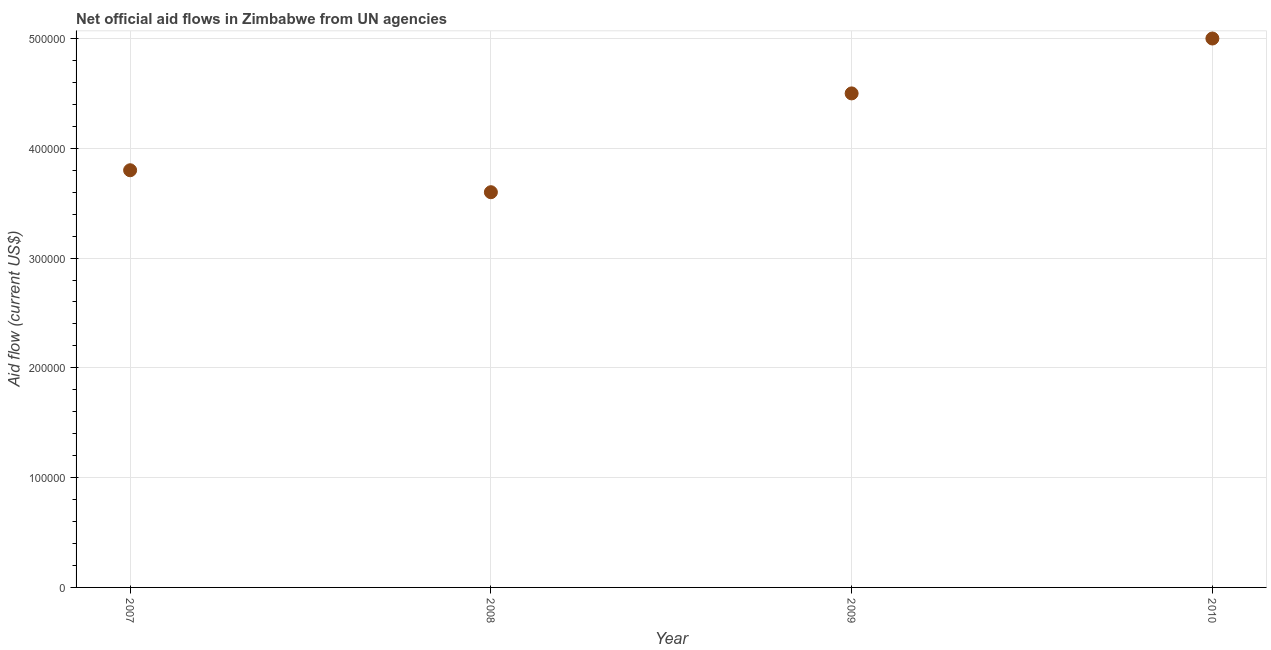What is the net official flows from un agencies in 2010?
Offer a very short reply. 5.00e+05. Across all years, what is the maximum net official flows from un agencies?
Keep it short and to the point. 5.00e+05. Across all years, what is the minimum net official flows from un agencies?
Offer a very short reply. 3.60e+05. In which year was the net official flows from un agencies maximum?
Offer a terse response. 2010. In which year was the net official flows from un agencies minimum?
Your response must be concise. 2008. What is the sum of the net official flows from un agencies?
Offer a terse response. 1.69e+06. What is the difference between the net official flows from un agencies in 2007 and 2008?
Make the answer very short. 2.00e+04. What is the average net official flows from un agencies per year?
Ensure brevity in your answer.  4.22e+05. What is the median net official flows from un agencies?
Your answer should be very brief. 4.15e+05. In how many years, is the net official flows from un agencies greater than 180000 US$?
Offer a very short reply. 4. What is the ratio of the net official flows from un agencies in 2008 to that in 2009?
Ensure brevity in your answer.  0.8. Is the net official flows from un agencies in 2009 less than that in 2010?
Your answer should be compact. Yes. Is the difference between the net official flows from un agencies in 2007 and 2008 greater than the difference between any two years?
Make the answer very short. No. What is the difference between the highest and the lowest net official flows from un agencies?
Your answer should be compact. 1.40e+05. How many dotlines are there?
Provide a succinct answer. 1. What is the difference between two consecutive major ticks on the Y-axis?
Give a very brief answer. 1.00e+05. What is the title of the graph?
Offer a very short reply. Net official aid flows in Zimbabwe from UN agencies. What is the Aid flow (current US$) in 2007?
Ensure brevity in your answer.  3.80e+05. What is the Aid flow (current US$) in 2008?
Ensure brevity in your answer.  3.60e+05. What is the Aid flow (current US$) in 2010?
Your response must be concise. 5.00e+05. What is the difference between the Aid flow (current US$) in 2007 and 2010?
Provide a succinct answer. -1.20e+05. What is the difference between the Aid flow (current US$) in 2008 and 2009?
Make the answer very short. -9.00e+04. What is the difference between the Aid flow (current US$) in 2008 and 2010?
Keep it short and to the point. -1.40e+05. What is the difference between the Aid flow (current US$) in 2009 and 2010?
Your response must be concise. -5.00e+04. What is the ratio of the Aid flow (current US$) in 2007 to that in 2008?
Your answer should be very brief. 1.06. What is the ratio of the Aid flow (current US$) in 2007 to that in 2009?
Give a very brief answer. 0.84. What is the ratio of the Aid flow (current US$) in 2007 to that in 2010?
Ensure brevity in your answer.  0.76. What is the ratio of the Aid flow (current US$) in 2008 to that in 2009?
Offer a very short reply. 0.8. What is the ratio of the Aid flow (current US$) in 2008 to that in 2010?
Ensure brevity in your answer.  0.72. 